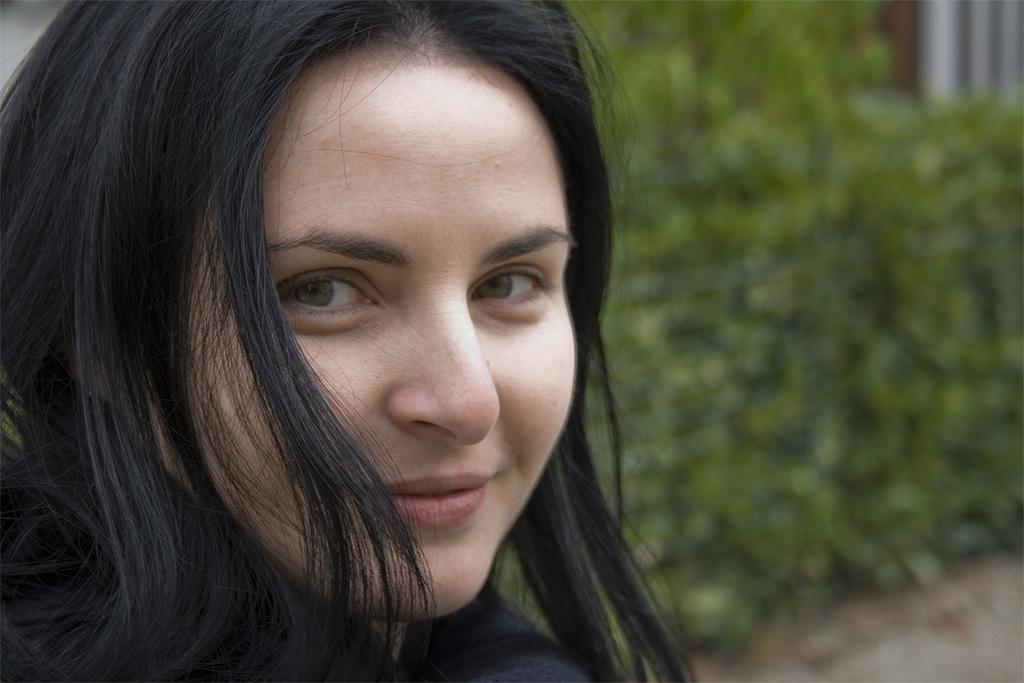Could you give a brief overview of what you see in this image? This image is taken outdoors. In the background there are a few plants with green leaves and stems. On the left side of the image there is a woman and she is with a smiling face. 